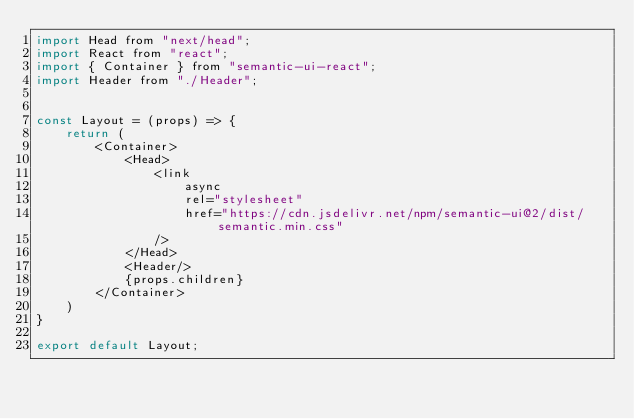<code> <loc_0><loc_0><loc_500><loc_500><_JavaScript_>import Head from "next/head";
import React from "react";
import { Container } from "semantic-ui-react";
import Header from "./Header";


const Layout = (props) => {
    return (
        <Container>
            <Head>
                <link
                    async
                    rel="stylesheet"
                    href="https://cdn.jsdelivr.net/npm/semantic-ui@2/dist/semantic.min.css"
                />
            </Head>
            <Header/>
            {props.children}
        </Container>
    )
}

export default Layout;</code> 